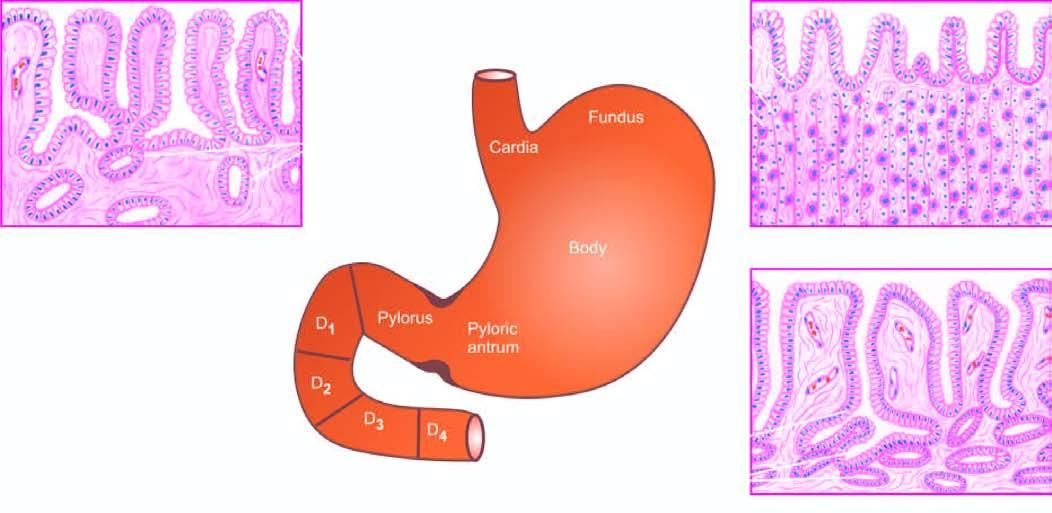re scanty connective tissue stroma the first to fourth parts of the duodenum?
Answer the question using a single word or phrase. No 